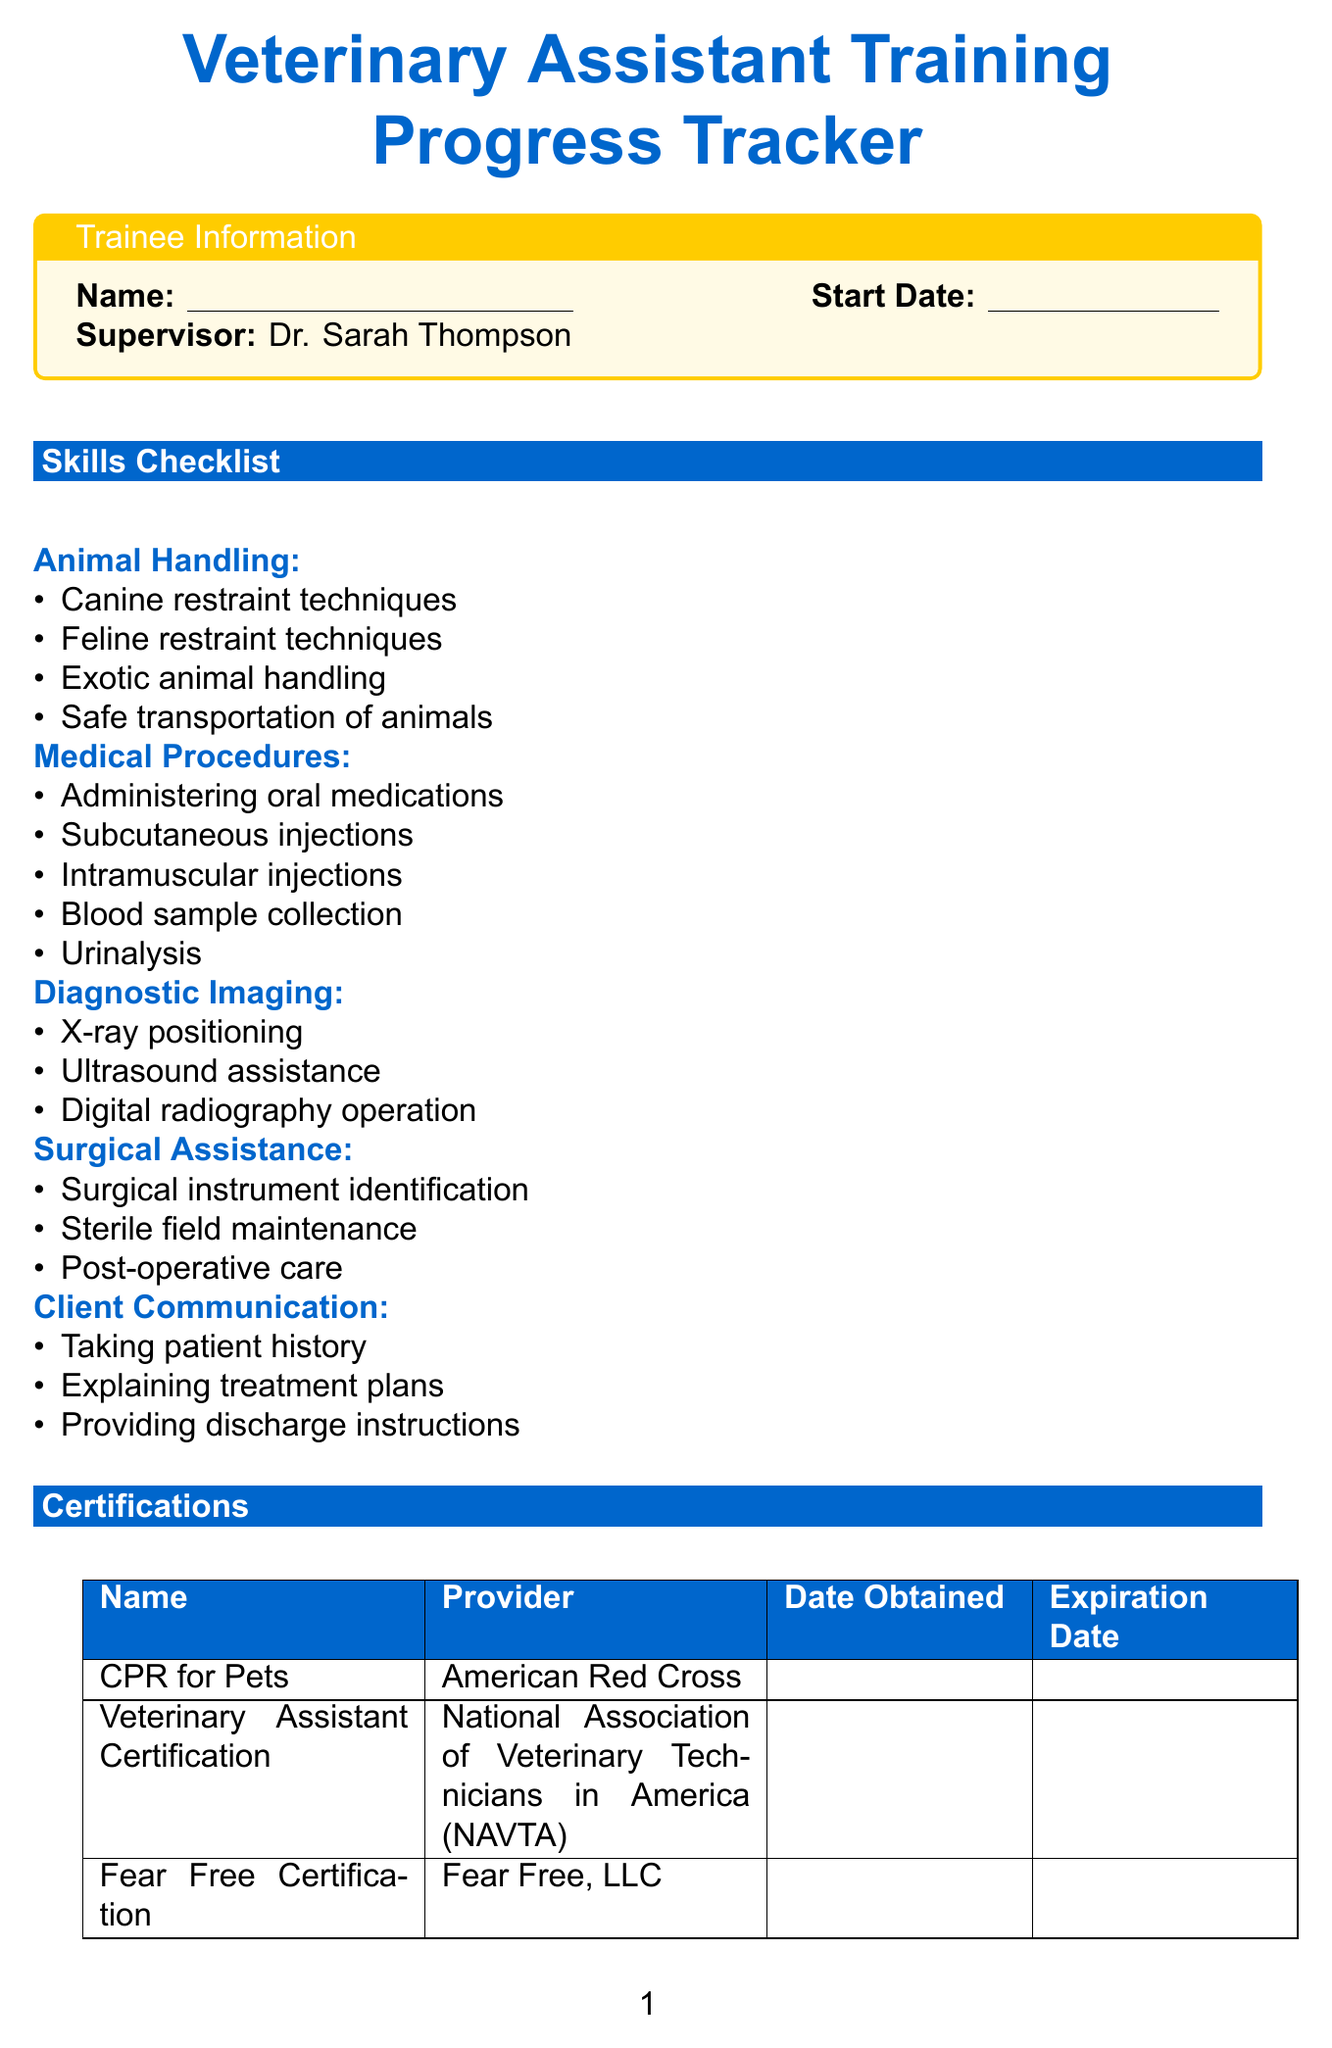What is the title of the form? The title of the form is displayed prominently at the top of the document.
Answer: Veterinary Assistant Training Progress Tracker Who is the supervisor? The supervisor's name is mentioned in the trainee information section of the document.
Answer: Dr. Sarah Thompson What is the address of the clinic? The address is located at the end of the document under the clinic information.
Answer: 1234 Pet Lane, Animalia, CA 90210 What are the evaluation periods mentioned? Evaluation periods are listed in the performance evaluation section of the document.
Answer: 3 months, 6 months, 1 year How many skills are listed in the Medical Procedures category? The number of skills can be counted in the skills checklist section under Medical Procedures.
Answer: 5 What is the primary color used in the document? The primary color is indicated in the document's color definitions and used throughout.
Answer: Blue What is included in the rating scale? The rating scale is specified in the performance evaluation section of the document.
Answer: Needs Improvement, Meets Expectations, Exceeds Expectations Which certification is provided by the American Red Cross? The specific certification obtained from the American Red Cross is noted in the certifications section.
Answer: CPR for Pets How many categories are in the evaluation criteria? The number of criteria categories is listed in the performance evaluation section.
Answer: 4 What does the last section of the document contain? The last section contains contact information for the clinic.
Answer: Contact information 